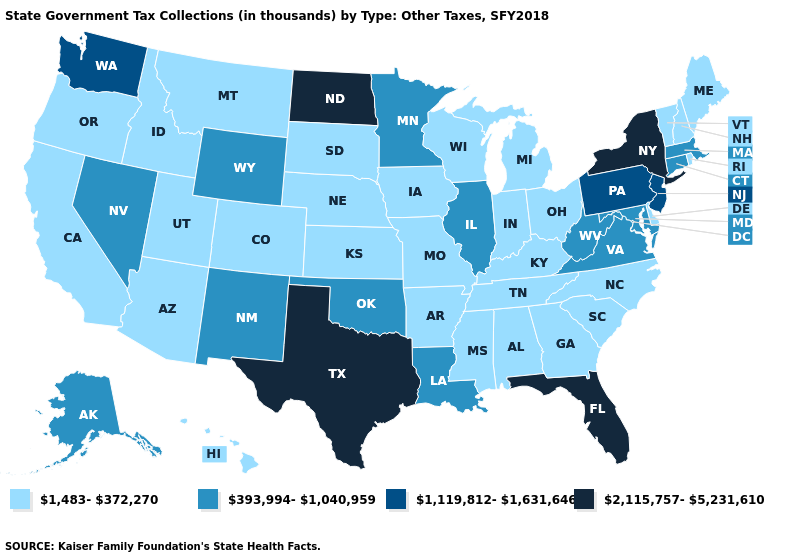What is the value of North Dakota?
Keep it brief. 2,115,757-5,231,610. Does the first symbol in the legend represent the smallest category?
Concise answer only. Yes. What is the value of Virginia?
Answer briefly. 393,994-1,040,959. Is the legend a continuous bar?
Quick response, please. No. How many symbols are there in the legend?
Keep it brief. 4. Among the states that border Florida , which have the highest value?
Quick response, please. Alabama, Georgia. What is the value of Louisiana?
Concise answer only. 393,994-1,040,959. Name the states that have a value in the range 1,119,812-1,631,646?
Short answer required. New Jersey, Pennsylvania, Washington. What is the value of Wyoming?
Quick response, please. 393,994-1,040,959. What is the lowest value in the MidWest?
Quick response, please. 1,483-372,270. Does Texas have the lowest value in the South?
Keep it brief. No. Which states have the lowest value in the USA?
Give a very brief answer. Alabama, Arizona, Arkansas, California, Colorado, Delaware, Georgia, Hawaii, Idaho, Indiana, Iowa, Kansas, Kentucky, Maine, Michigan, Mississippi, Missouri, Montana, Nebraska, New Hampshire, North Carolina, Ohio, Oregon, Rhode Island, South Carolina, South Dakota, Tennessee, Utah, Vermont, Wisconsin. Name the states that have a value in the range 393,994-1,040,959?
Concise answer only. Alaska, Connecticut, Illinois, Louisiana, Maryland, Massachusetts, Minnesota, Nevada, New Mexico, Oklahoma, Virginia, West Virginia, Wyoming. Does Washington have the highest value in the West?
Quick response, please. Yes. Which states hav the highest value in the South?
Be succinct. Florida, Texas. 